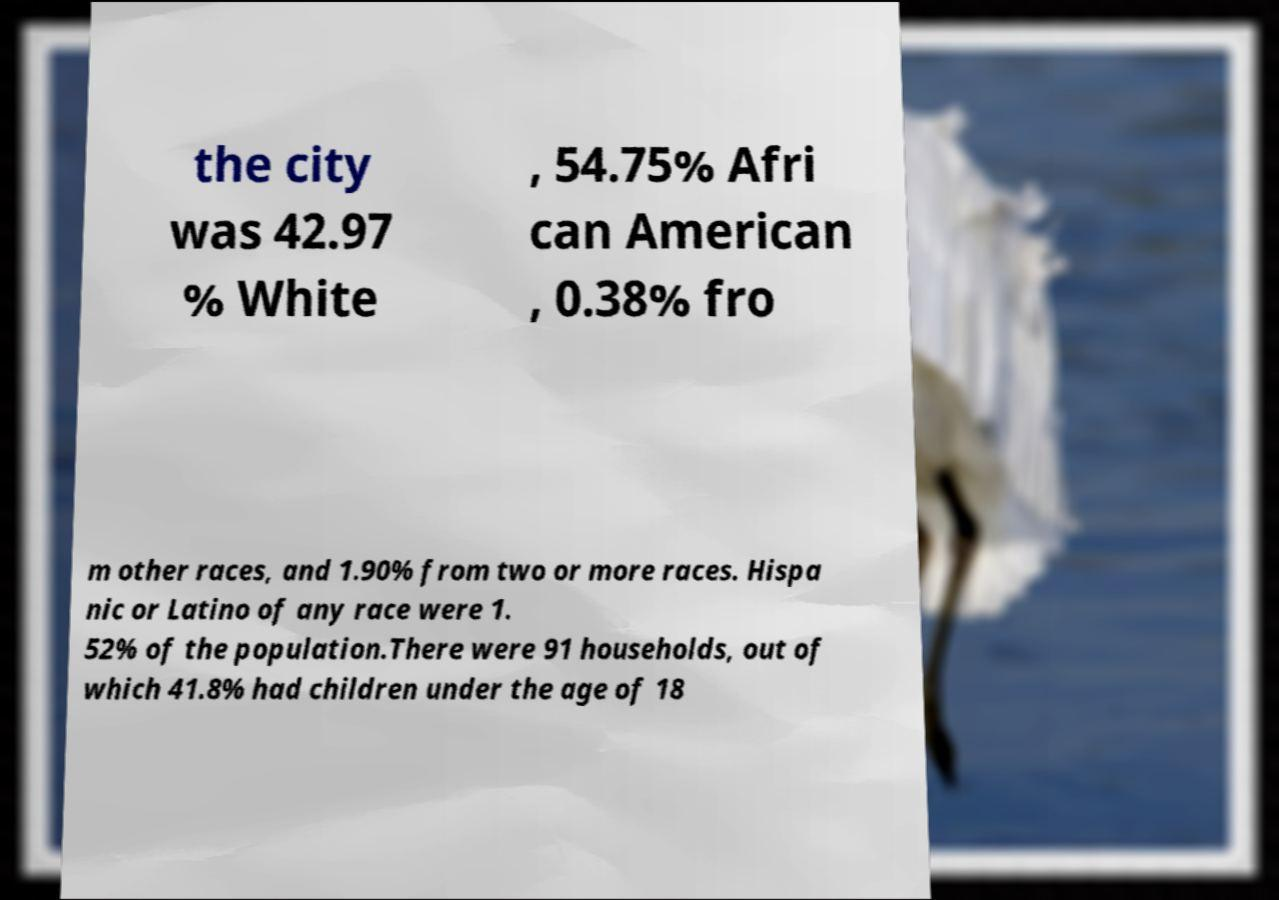Please read and relay the text visible in this image. What does it say? the city was 42.97 % White , 54.75% Afri can American , 0.38% fro m other races, and 1.90% from two or more races. Hispa nic or Latino of any race were 1. 52% of the population.There were 91 households, out of which 41.8% had children under the age of 18 